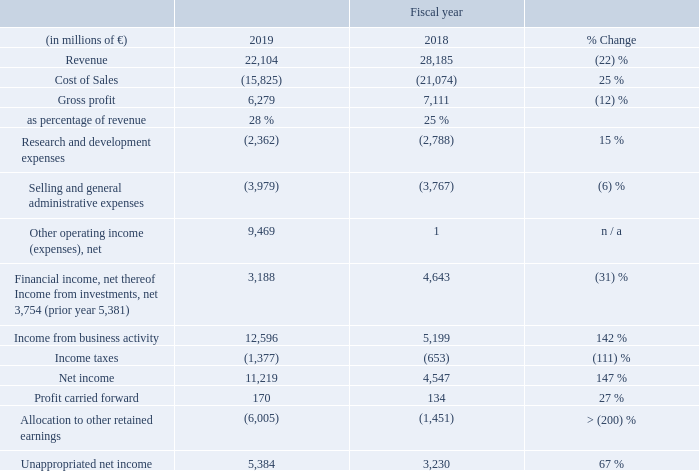A.9.1 Results of operations
Statement of Income of Siemens AG in accordance with German Commercial Code (condensed)
Beginning of August 2018, Siemens AG carved out its mobility business to Siemens Mobility GmbH by way of singular succession. The decreases in revenue, cost of sales, gross profit and research and development (R & D) expenses were mainly driven by this carve-out.
On a geographical basis, 75 % of revenue was generated in the Europe, C. I. S., Africa, Middle East region, 18 % in the Asia, Australia region and 7 % in the Americas region. Exports from Germany accounted for 62 % of overall revenue. In fiscal 2019, orders for Siemens AG amounted to € 21.6 billion. Within Siemens AG, the development of revenue depends strongly on the completion of contracts, primarily in connection with large orders.
The R & D intensity (R & D as a percentage of revenue) increased by 0.8 percentage points year-over-year. The research and development activities of Siemens AG are fundamentally the same as for its fields of business activities within the Siemens Group, respectively. On an average basis, we employed 9,000 people in R & D in fiscal 2019.
The decrease in Financial income, net was primarily attributable to lower income from investments, net. The main factor for this decrease was a significant income from the profit transfer agreement with Siemens Beteiligungen Inland GmbH, Germany, in
fiscal 2018.
What is the revenue break up based on geography? On a geographical basis, 75 % of revenue was generated in the europe, c. i. s., africa, middle east region, 18 % in the asia, australia region and 7 % in the americas region. What caused the decrease in revenue, cost of sales, gross profit and research and development (R&D) expenses? The decreases in revenue, cost of sales, gross profit and research and development (r & d) expenses were mainly driven by this carve-out. On an average how many people are employed in R&D in fiscal in 2019? 9,000. What is the average revenue for 2019 and 2018?
Answer scale should be: million. (22,104 + 28,185) / 2
Answer: 25144.5. What is the gross profit margin in 2019?
Answer scale should be: percent. 6,279 / 22,104
Answer: 28.41. What is the increase / (decrease) in Net Income from 2018 to 2019?
Answer scale should be: million. 11,219 - 4,547
Answer: 6672. 